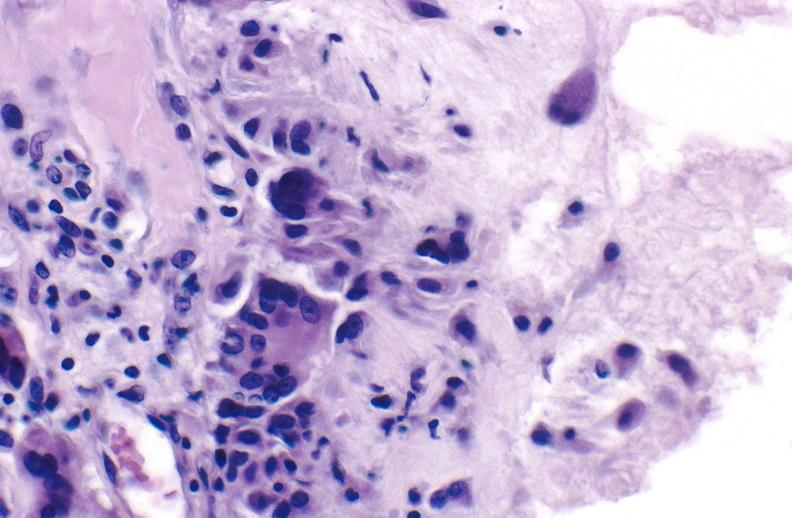what does this image show?
Answer the question using a single word or phrase. Gout 